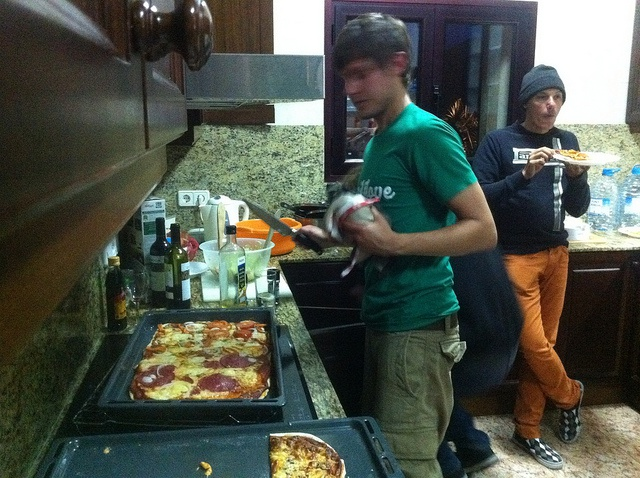Describe the objects in this image and their specific colors. I can see people in black, gray, teal, and darkgreen tones, people in black, maroon, brown, and gray tones, pizza in black, tan, olive, maroon, and khaki tones, pizza in black, khaki, tan, and olive tones, and bottle in black, gray, darkgreen, and lightblue tones in this image. 